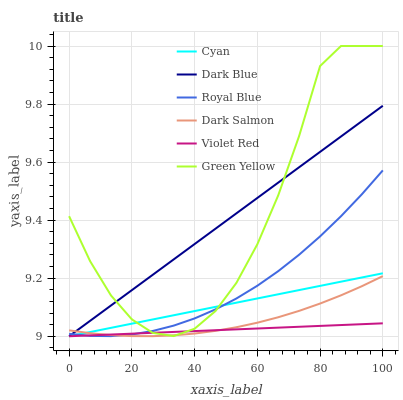Does Violet Red have the minimum area under the curve?
Answer yes or no. Yes. Does Dark Blue have the maximum area under the curve?
Answer yes or no. Yes. Does Dark Salmon have the minimum area under the curve?
Answer yes or no. No. Does Dark Salmon have the maximum area under the curve?
Answer yes or no. No. Is Cyan the smoothest?
Answer yes or no. Yes. Is Green Yellow the roughest?
Answer yes or no. Yes. Is Dark Blue the smoothest?
Answer yes or no. No. Is Dark Blue the roughest?
Answer yes or no. No. Does Violet Red have the lowest value?
Answer yes or no. Yes. Does Dark Salmon have the lowest value?
Answer yes or no. No. Does Green Yellow have the highest value?
Answer yes or no. Yes. Does Dark Blue have the highest value?
Answer yes or no. No. Does Dark Salmon intersect Dark Blue?
Answer yes or no. Yes. Is Dark Salmon less than Dark Blue?
Answer yes or no. No. Is Dark Salmon greater than Dark Blue?
Answer yes or no. No. 